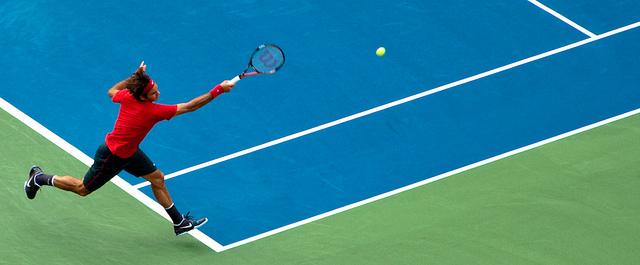What color is the court?
Be succinct. Blue. What sport is being played?
Answer briefly. Tennis. What company made the tennis racket?
Quick response, please. Wilson. 